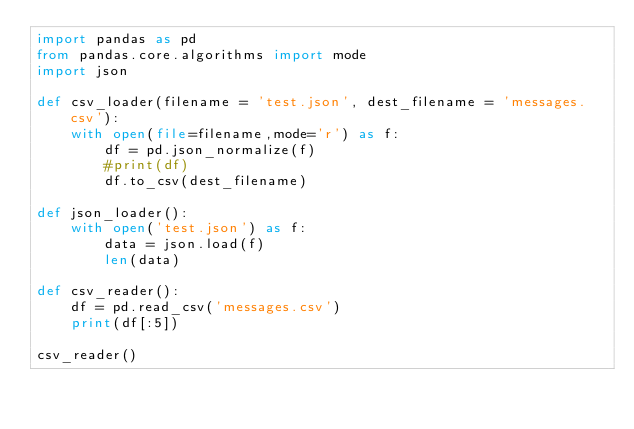<code> <loc_0><loc_0><loc_500><loc_500><_Python_>import pandas as pd
from pandas.core.algorithms import mode
import json

def csv_loader(filename = 'test.json', dest_filename = 'messages.csv'):
    with open(file=filename,mode='r') as f:
        df = pd.json_normalize(f)
        #print(df)
        df.to_csv(dest_filename)

def json_loader():
    with open('test.json') as f:
        data = json.load(f)
        len(data)

def csv_reader():
    df = pd.read_csv('messages.csv')
    print(df[:5])

csv_reader()</code> 